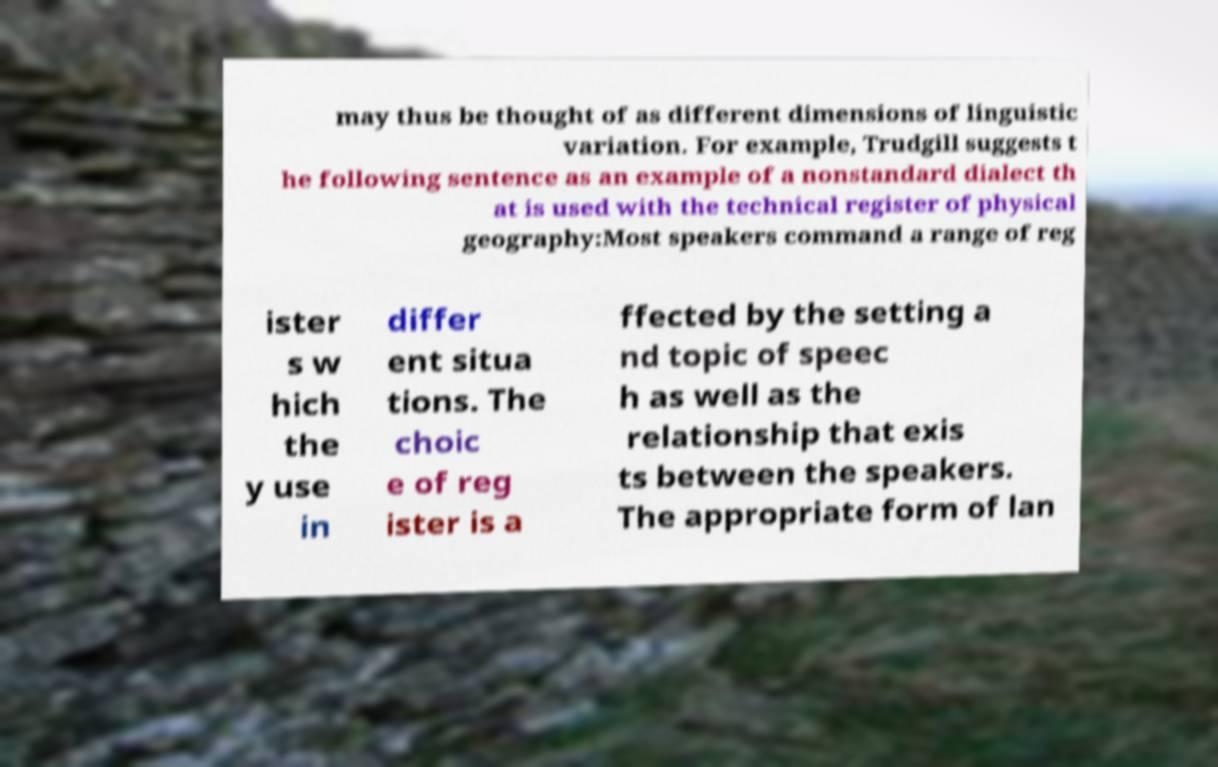There's text embedded in this image that I need extracted. Can you transcribe it verbatim? may thus be thought of as different dimensions of linguistic variation. For example, Trudgill suggests t he following sentence as an example of a nonstandard dialect th at is used with the technical register of physical geography:Most speakers command a range of reg ister s w hich the y use in differ ent situa tions. The choic e of reg ister is a ffected by the setting a nd topic of speec h as well as the relationship that exis ts between the speakers. The appropriate form of lan 